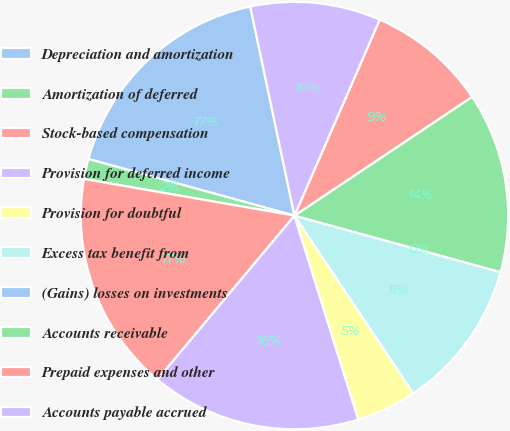<chart> <loc_0><loc_0><loc_500><loc_500><pie_chart><fcel>Depreciation and amortization<fcel>Amortization of deferred<fcel>Stock-based compensation<fcel>Provision for deferred income<fcel>Provision for doubtful<fcel>Excess tax benefit from<fcel>(Gains) losses on investments<fcel>Accounts receivable<fcel>Prepaid expenses and other<fcel>Accounts payable accrued<nl><fcel>17.42%<fcel>1.52%<fcel>16.67%<fcel>15.91%<fcel>4.55%<fcel>11.36%<fcel>0.0%<fcel>13.64%<fcel>9.09%<fcel>9.85%<nl></chart> 